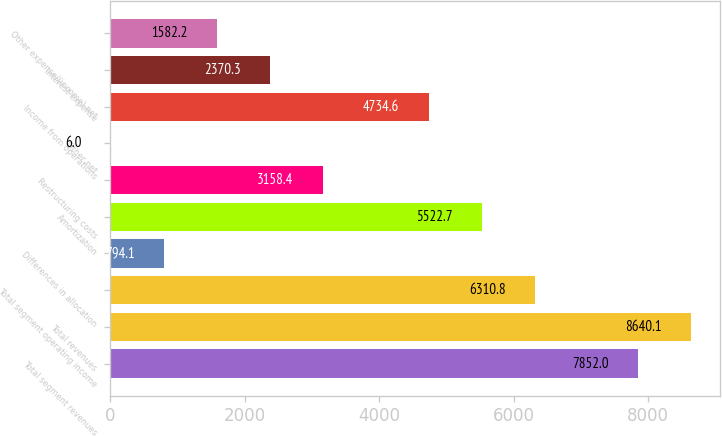Convert chart. <chart><loc_0><loc_0><loc_500><loc_500><bar_chart><fcel>Total segment revenues<fcel>Total revenues<fcel>Total segment operating income<fcel>Differences in allocation<fcel>Amortization<fcel>Restructuring costs<fcel>Other net<fcel>Income from operations<fcel>Interest expense<fcel>Other expense/(income) net<nl><fcel>7852<fcel>8640.1<fcel>6310.8<fcel>794.1<fcel>5522.7<fcel>3158.4<fcel>6<fcel>4734.6<fcel>2370.3<fcel>1582.2<nl></chart> 